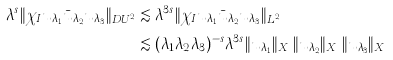<formula> <loc_0><loc_0><loc_500><loc_500>\lambda ^ { s } \| \chi _ { I } u _ { \lambda _ { 1 } } \bar { u } _ { \lambda _ { 2 } } u _ { \lambda _ { 3 } } \| _ { D U ^ { 2 } _ { \lambda } } & \lesssim \lambda ^ { 3 s } \| \chi _ { I } u _ { \lambda _ { 1 } } \bar { u } _ { \lambda _ { 2 } } u _ { \lambda _ { 3 } } \| _ { L ^ { 2 } } \\ & \lesssim ( \lambda _ { 1 } \lambda _ { 2 } \lambda _ { 3 } ) ^ { - s } \lambda ^ { 3 s } \| u _ { \lambda _ { 1 } } \| _ { X ^ { s } } \| u _ { \lambda _ { 2 } } \| _ { X ^ { s } } \| u _ { \lambda _ { 3 } } \| _ { X ^ { s } }</formula> 